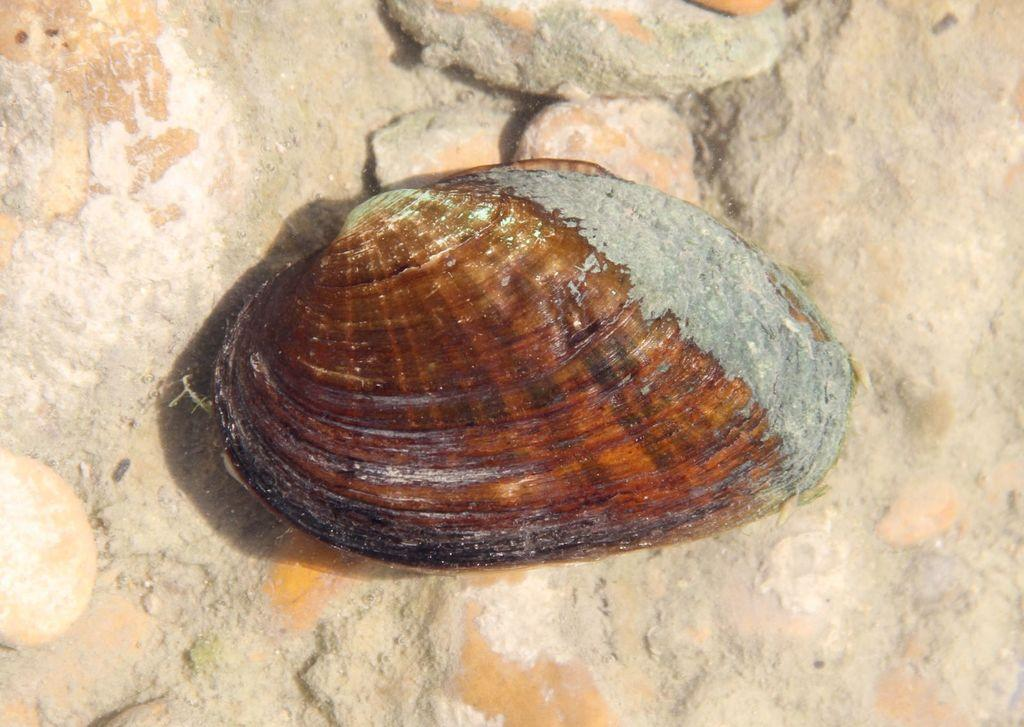What object can be seen in the image? There is a shell in the image. What is the color of the shell? The shell is brown in color. Can you see a tiger walking in the image? No, there is no tiger or any indication of a tiger walking in the image. 